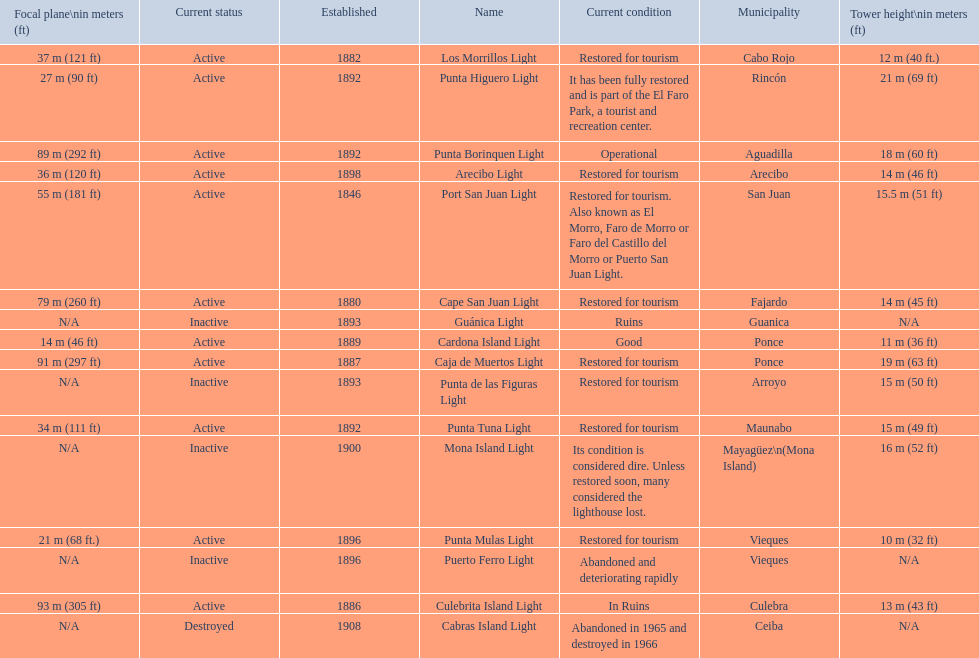How many establishments are restored for tourism? 9. 